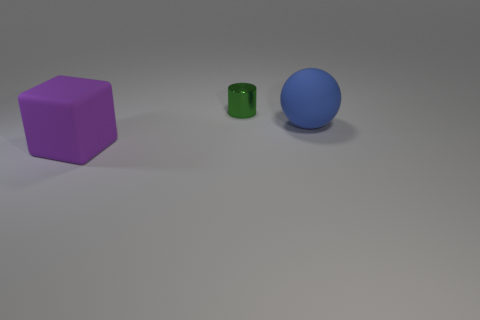Is there any other thing that has the same material as the green cylinder?
Your answer should be compact. No. What is the color of the object in front of the big thing that is behind the object that is in front of the blue sphere?
Offer a terse response. Purple. How many blue cylinders are the same size as the ball?
Your answer should be very brief. 0. Are there more matte objects in front of the shiny cylinder than purple matte blocks to the right of the rubber block?
Provide a short and direct response. Yes. The big rubber object that is in front of the rubber thing right of the green metallic thing is what color?
Your response must be concise. Purple. Are the purple cube and the large ball made of the same material?
Provide a succinct answer. Yes. Is the size of the matte thing that is behind the purple matte block the same as the metallic thing on the right side of the rubber cube?
Offer a terse response. No. How many rubber things are on the right side of the purple cube and left of the small green metallic thing?
Provide a short and direct response. 0. How many objects are large purple matte objects or things that are on the left side of the small green object?
Provide a short and direct response. 1. There is a thing that is to the right of the tiny metallic thing; what is its color?
Keep it short and to the point. Blue. 